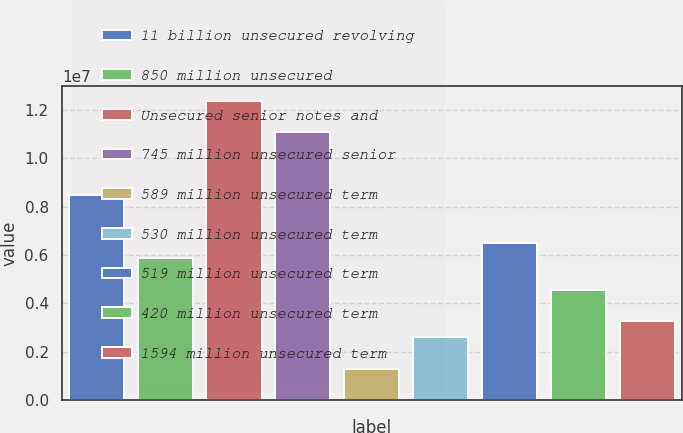<chart> <loc_0><loc_0><loc_500><loc_500><bar_chart><fcel>11 billion unsecured revolving<fcel>850 million unsecured<fcel>Unsecured senior notes and<fcel>745 million unsecured senior<fcel>589 million unsecured term<fcel>530 million unsecured term<fcel>519 million unsecured term<fcel>420 million unsecured term<fcel>1594 million unsecured term<nl><fcel>8.46324e+06<fcel>5.86082e+06<fcel>1.23669e+07<fcel>1.10657e+07<fcel>1.3066e+06<fcel>2.6078e+06<fcel>6.51143e+06<fcel>4.55962e+06<fcel>3.25841e+06<nl></chart> 